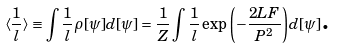Convert formula to latex. <formula><loc_0><loc_0><loc_500><loc_500>\langle \frac { 1 } { l } \rangle \equiv \int \frac { 1 } { l } \rho [ \psi ] d [ \psi ] = \frac { 1 } { Z } \int \frac { 1 } { l } \exp { \left ( - \frac { 2 L F } { P ^ { 2 } } \right ) } d [ \psi ] \text {.}</formula> 